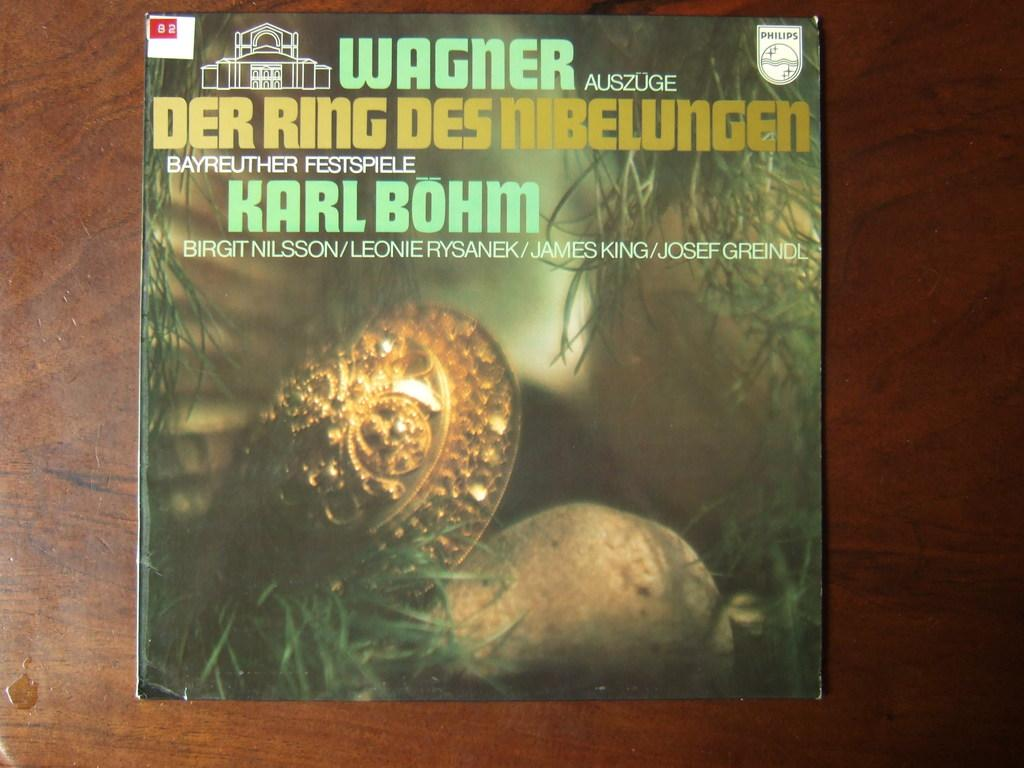<image>
Summarize the visual content of the image. A case for something with a snail on the cover and German text. 